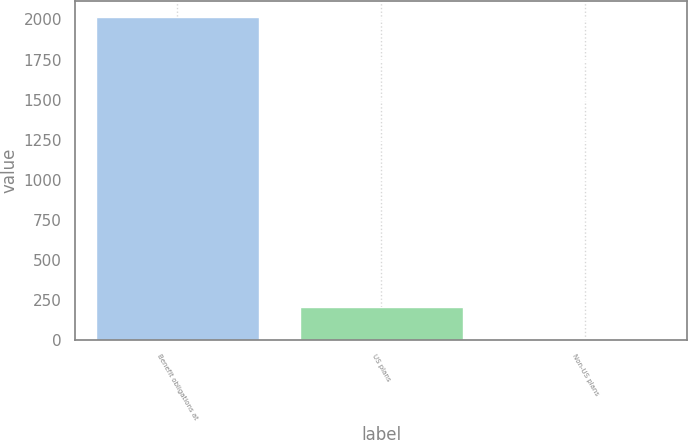Convert chart to OTSL. <chart><loc_0><loc_0><loc_500><loc_500><bar_chart><fcel>Benefit obligations at<fcel>US plans<fcel>Non-US plans<nl><fcel>2014<fcel>204.82<fcel>3.8<nl></chart> 